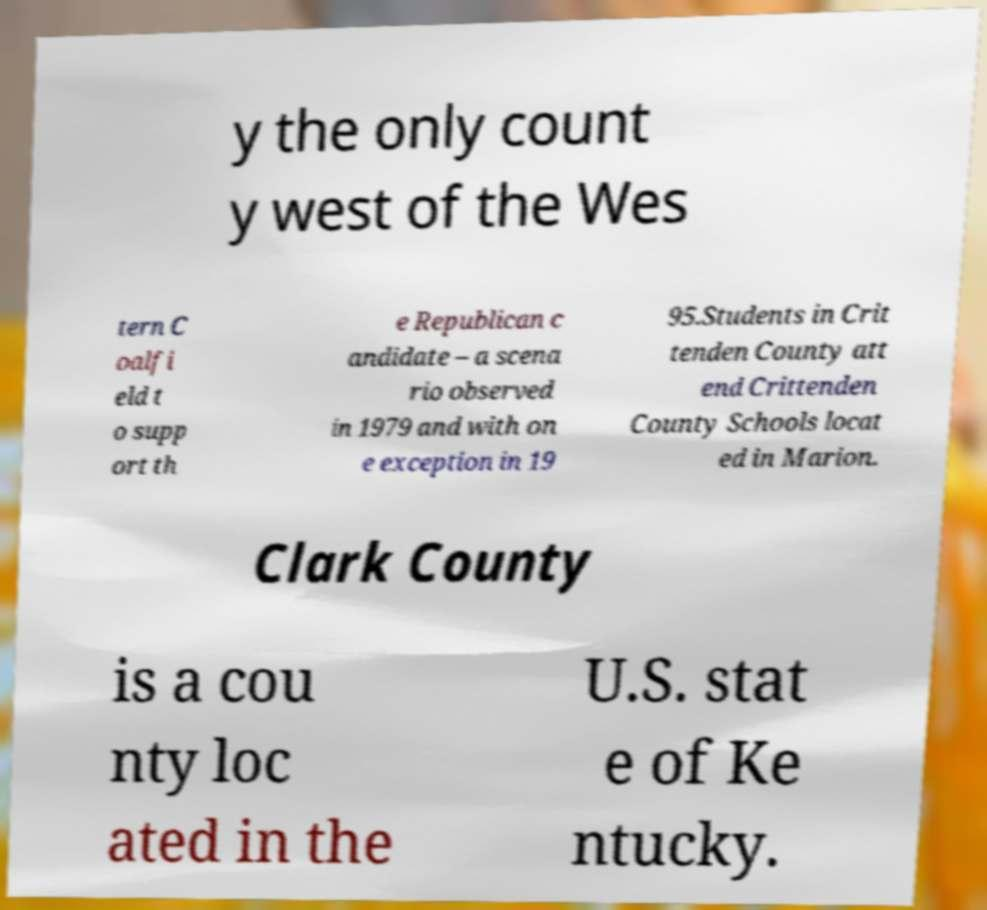Please identify and transcribe the text found in this image. y the only count y west of the Wes tern C oalfi eld t o supp ort th e Republican c andidate – a scena rio observed in 1979 and with on e exception in 19 95.Students in Crit tenden County att end Crittenden County Schools locat ed in Marion. Clark County is a cou nty loc ated in the U.S. stat e of Ke ntucky. 